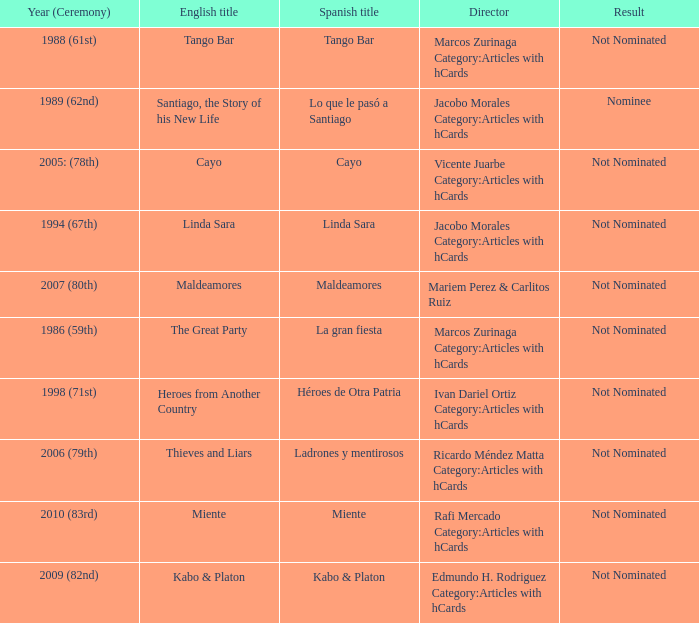Who was the director for Tango Bar? Marcos Zurinaga Category:Articles with hCards. Write the full table. {'header': ['Year (Ceremony)', 'English title', 'Spanish title', 'Director', 'Result'], 'rows': [['1988 (61st)', 'Tango Bar', 'Tango Bar', 'Marcos Zurinaga Category:Articles with hCards', 'Not Nominated'], ['1989 (62nd)', 'Santiago, the Story of his New Life', 'Lo que le pasó a Santiago', 'Jacobo Morales Category:Articles with hCards', 'Nominee'], ['2005: (78th)', 'Cayo', 'Cayo', 'Vicente Juarbe Category:Articles with hCards', 'Not Nominated'], ['1994 (67th)', 'Linda Sara', 'Linda Sara', 'Jacobo Morales Category:Articles with hCards', 'Not Nominated'], ['2007 (80th)', 'Maldeamores', 'Maldeamores', 'Mariem Perez & Carlitos Ruiz', 'Not Nominated'], ['1986 (59th)', 'The Great Party', 'La gran fiesta', 'Marcos Zurinaga Category:Articles with hCards', 'Not Nominated'], ['1998 (71st)', 'Heroes from Another Country', 'Héroes de Otra Patria', 'Ivan Dariel Ortiz Category:Articles with hCards', 'Not Nominated'], ['2006 (79th)', 'Thieves and Liars', 'Ladrones y mentirosos', 'Ricardo Méndez Matta Category:Articles with hCards', 'Not Nominated'], ['2010 (83rd)', 'Miente', 'Miente', 'Rafi Mercado Category:Articles with hCards', 'Not Nominated'], ['2009 (82nd)', 'Kabo & Platon', 'Kabo & Platon', 'Edmundo H. Rodriguez Category:Articles with hCards', 'Not Nominated']]} 